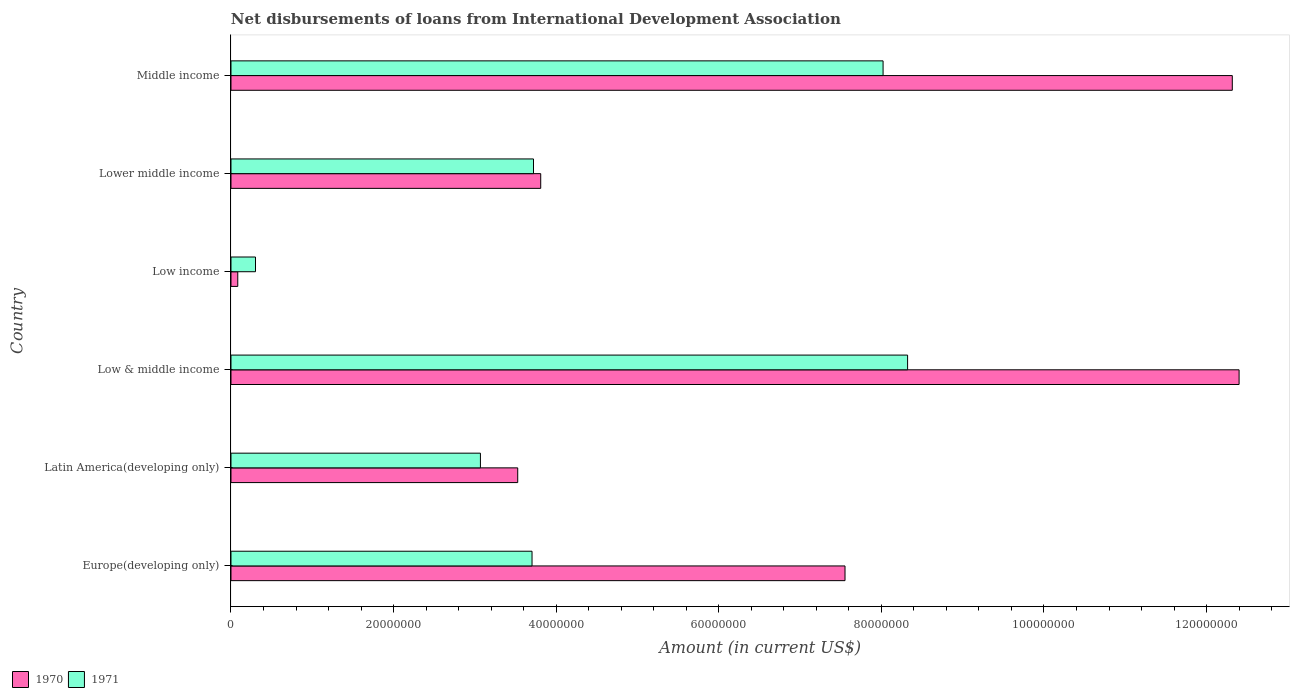How many different coloured bars are there?
Give a very brief answer. 2. Are the number of bars on each tick of the Y-axis equal?
Provide a short and direct response. Yes. How many bars are there on the 6th tick from the top?
Ensure brevity in your answer.  2. How many bars are there on the 1st tick from the bottom?
Your answer should be compact. 2. What is the amount of loans disbursed in 1971 in Middle income?
Offer a terse response. 8.02e+07. Across all countries, what is the maximum amount of loans disbursed in 1971?
Offer a very short reply. 8.32e+07. Across all countries, what is the minimum amount of loans disbursed in 1971?
Provide a succinct answer. 3.02e+06. In which country was the amount of loans disbursed in 1970 maximum?
Your answer should be very brief. Low & middle income. What is the total amount of loans disbursed in 1970 in the graph?
Offer a terse response. 3.97e+08. What is the difference between the amount of loans disbursed in 1971 in Low income and that in Middle income?
Your response must be concise. -7.72e+07. What is the difference between the amount of loans disbursed in 1971 in Low & middle income and the amount of loans disbursed in 1970 in Latin America(developing only)?
Your answer should be very brief. 4.80e+07. What is the average amount of loans disbursed in 1970 per country?
Provide a succinct answer. 6.61e+07. What is the difference between the amount of loans disbursed in 1971 and amount of loans disbursed in 1970 in Middle income?
Keep it short and to the point. -4.30e+07. In how many countries, is the amount of loans disbursed in 1970 greater than 68000000 US$?
Your answer should be very brief. 3. What is the ratio of the amount of loans disbursed in 1970 in Low income to that in Middle income?
Ensure brevity in your answer.  0.01. Is the amount of loans disbursed in 1970 in Europe(developing only) less than that in Low income?
Make the answer very short. No. What is the difference between the highest and the second highest amount of loans disbursed in 1971?
Keep it short and to the point. 3.02e+06. What is the difference between the highest and the lowest amount of loans disbursed in 1971?
Make the answer very short. 8.02e+07. How many countries are there in the graph?
Your answer should be very brief. 6. Are the values on the major ticks of X-axis written in scientific E-notation?
Offer a very short reply. No. What is the title of the graph?
Your answer should be very brief. Net disbursements of loans from International Development Association. Does "1991" appear as one of the legend labels in the graph?
Offer a terse response. No. What is the label or title of the Y-axis?
Give a very brief answer. Country. What is the Amount (in current US$) in 1970 in Europe(developing only)?
Your response must be concise. 7.55e+07. What is the Amount (in current US$) in 1971 in Europe(developing only)?
Ensure brevity in your answer.  3.70e+07. What is the Amount (in current US$) in 1970 in Latin America(developing only)?
Make the answer very short. 3.53e+07. What is the Amount (in current US$) in 1971 in Latin America(developing only)?
Ensure brevity in your answer.  3.07e+07. What is the Amount (in current US$) of 1970 in Low & middle income?
Make the answer very short. 1.24e+08. What is the Amount (in current US$) in 1971 in Low & middle income?
Offer a very short reply. 8.32e+07. What is the Amount (in current US$) in 1970 in Low income?
Your response must be concise. 8.35e+05. What is the Amount (in current US$) in 1971 in Low income?
Keep it short and to the point. 3.02e+06. What is the Amount (in current US$) in 1970 in Lower middle income?
Make the answer very short. 3.81e+07. What is the Amount (in current US$) of 1971 in Lower middle income?
Keep it short and to the point. 3.72e+07. What is the Amount (in current US$) of 1970 in Middle income?
Ensure brevity in your answer.  1.23e+08. What is the Amount (in current US$) in 1971 in Middle income?
Offer a very short reply. 8.02e+07. Across all countries, what is the maximum Amount (in current US$) in 1970?
Your answer should be compact. 1.24e+08. Across all countries, what is the maximum Amount (in current US$) in 1971?
Make the answer very short. 8.32e+07. Across all countries, what is the minimum Amount (in current US$) of 1970?
Your answer should be very brief. 8.35e+05. Across all countries, what is the minimum Amount (in current US$) in 1971?
Make the answer very short. 3.02e+06. What is the total Amount (in current US$) in 1970 in the graph?
Offer a very short reply. 3.97e+08. What is the total Amount (in current US$) of 1971 in the graph?
Provide a short and direct response. 2.71e+08. What is the difference between the Amount (in current US$) in 1970 in Europe(developing only) and that in Latin America(developing only)?
Give a very brief answer. 4.03e+07. What is the difference between the Amount (in current US$) of 1971 in Europe(developing only) and that in Latin America(developing only)?
Offer a very short reply. 6.35e+06. What is the difference between the Amount (in current US$) in 1970 in Europe(developing only) and that in Low & middle income?
Provide a short and direct response. -4.85e+07. What is the difference between the Amount (in current US$) in 1971 in Europe(developing only) and that in Low & middle income?
Offer a very short reply. -4.62e+07. What is the difference between the Amount (in current US$) of 1970 in Europe(developing only) and that in Low income?
Your response must be concise. 7.47e+07. What is the difference between the Amount (in current US$) in 1971 in Europe(developing only) and that in Low income?
Your response must be concise. 3.40e+07. What is the difference between the Amount (in current US$) in 1970 in Europe(developing only) and that in Lower middle income?
Offer a terse response. 3.74e+07. What is the difference between the Amount (in current US$) in 1971 in Europe(developing only) and that in Lower middle income?
Ensure brevity in your answer.  -1.81e+05. What is the difference between the Amount (in current US$) in 1970 in Europe(developing only) and that in Middle income?
Provide a succinct answer. -4.76e+07. What is the difference between the Amount (in current US$) of 1971 in Europe(developing only) and that in Middle income?
Make the answer very short. -4.32e+07. What is the difference between the Amount (in current US$) of 1970 in Latin America(developing only) and that in Low & middle income?
Ensure brevity in your answer.  -8.87e+07. What is the difference between the Amount (in current US$) of 1971 in Latin America(developing only) and that in Low & middle income?
Your answer should be very brief. -5.25e+07. What is the difference between the Amount (in current US$) in 1970 in Latin America(developing only) and that in Low income?
Offer a very short reply. 3.44e+07. What is the difference between the Amount (in current US$) of 1971 in Latin America(developing only) and that in Low income?
Offer a very short reply. 2.77e+07. What is the difference between the Amount (in current US$) of 1970 in Latin America(developing only) and that in Lower middle income?
Your answer should be compact. -2.83e+06. What is the difference between the Amount (in current US$) in 1971 in Latin America(developing only) and that in Lower middle income?
Your answer should be compact. -6.53e+06. What is the difference between the Amount (in current US$) of 1970 in Latin America(developing only) and that in Middle income?
Offer a very short reply. -8.79e+07. What is the difference between the Amount (in current US$) in 1971 in Latin America(developing only) and that in Middle income?
Offer a very short reply. -4.95e+07. What is the difference between the Amount (in current US$) in 1970 in Low & middle income and that in Low income?
Make the answer very short. 1.23e+08. What is the difference between the Amount (in current US$) in 1971 in Low & middle income and that in Low income?
Ensure brevity in your answer.  8.02e+07. What is the difference between the Amount (in current US$) of 1970 in Low & middle income and that in Lower middle income?
Make the answer very short. 8.59e+07. What is the difference between the Amount (in current US$) in 1971 in Low & middle income and that in Lower middle income?
Provide a succinct answer. 4.60e+07. What is the difference between the Amount (in current US$) of 1970 in Low & middle income and that in Middle income?
Provide a short and direct response. 8.35e+05. What is the difference between the Amount (in current US$) of 1971 in Low & middle income and that in Middle income?
Your response must be concise. 3.02e+06. What is the difference between the Amount (in current US$) of 1970 in Low income and that in Lower middle income?
Offer a terse response. -3.73e+07. What is the difference between the Amount (in current US$) of 1971 in Low income and that in Lower middle income?
Your response must be concise. -3.42e+07. What is the difference between the Amount (in current US$) of 1970 in Low income and that in Middle income?
Your answer should be very brief. -1.22e+08. What is the difference between the Amount (in current US$) of 1971 in Low income and that in Middle income?
Provide a short and direct response. -7.72e+07. What is the difference between the Amount (in current US$) of 1970 in Lower middle income and that in Middle income?
Your answer should be very brief. -8.51e+07. What is the difference between the Amount (in current US$) of 1971 in Lower middle income and that in Middle income?
Give a very brief answer. -4.30e+07. What is the difference between the Amount (in current US$) of 1970 in Europe(developing only) and the Amount (in current US$) of 1971 in Latin America(developing only)?
Give a very brief answer. 4.48e+07. What is the difference between the Amount (in current US$) of 1970 in Europe(developing only) and the Amount (in current US$) of 1971 in Low & middle income?
Your response must be concise. -7.70e+06. What is the difference between the Amount (in current US$) of 1970 in Europe(developing only) and the Amount (in current US$) of 1971 in Low income?
Keep it short and to the point. 7.25e+07. What is the difference between the Amount (in current US$) of 1970 in Europe(developing only) and the Amount (in current US$) of 1971 in Lower middle income?
Offer a terse response. 3.83e+07. What is the difference between the Amount (in current US$) of 1970 in Europe(developing only) and the Amount (in current US$) of 1971 in Middle income?
Your answer should be compact. -4.68e+06. What is the difference between the Amount (in current US$) of 1970 in Latin America(developing only) and the Amount (in current US$) of 1971 in Low & middle income?
Your answer should be very brief. -4.80e+07. What is the difference between the Amount (in current US$) of 1970 in Latin America(developing only) and the Amount (in current US$) of 1971 in Low income?
Provide a short and direct response. 3.23e+07. What is the difference between the Amount (in current US$) in 1970 in Latin America(developing only) and the Amount (in current US$) in 1971 in Lower middle income?
Offer a terse response. -1.94e+06. What is the difference between the Amount (in current US$) of 1970 in Latin America(developing only) and the Amount (in current US$) of 1971 in Middle income?
Your response must be concise. -4.49e+07. What is the difference between the Amount (in current US$) in 1970 in Low & middle income and the Amount (in current US$) in 1971 in Low income?
Keep it short and to the point. 1.21e+08. What is the difference between the Amount (in current US$) in 1970 in Low & middle income and the Amount (in current US$) in 1971 in Lower middle income?
Make the answer very short. 8.68e+07. What is the difference between the Amount (in current US$) in 1970 in Low & middle income and the Amount (in current US$) in 1971 in Middle income?
Give a very brief answer. 4.38e+07. What is the difference between the Amount (in current US$) in 1970 in Low income and the Amount (in current US$) in 1971 in Lower middle income?
Your answer should be compact. -3.64e+07. What is the difference between the Amount (in current US$) of 1970 in Low income and the Amount (in current US$) of 1971 in Middle income?
Keep it short and to the point. -7.94e+07. What is the difference between the Amount (in current US$) in 1970 in Lower middle income and the Amount (in current US$) in 1971 in Middle income?
Your answer should be compact. -4.21e+07. What is the average Amount (in current US$) of 1970 per country?
Your response must be concise. 6.61e+07. What is the average Amount (in current US$) of 1971 per country?
Offer a terse response. 4.52e+07. What is the difference between the Amount (in current US$) of 1970 and Amount (in current US$) of 1971 in Europe(developing only)?
Ensure brevity in your answer.  3.85e+07. What is the difference between the Amount (in current US$) of 1970 and Amount (in current US$) of 1971 in Latin America(developing only)?
Keep it short and to the point. 4.59e+06. What is the difference between the Amount (in current US$) in 1970 and Amount (in current US$) in 1971 in Low & middle income?
Your response must be concise. 4.08e+07. What is the difference between the Amount (in current US$) of 1970 and Amount (in current US$) of 1971 in Low income?
Give a very brief answer. -2.18e+06. What is the difference between the Amount (in current US$) of 1970 and Amount (in current US$) of 1971 in Lower middle income?
Your answer should be compact. 8.88e+05. What is the difference between the Amount (in current US$) of 1970 and Amount (in current US$) of 1971 in Middle income?
Ensure brevity in your answer.  4.30e+07. What is the ratio of the Amount (in current US$) of 1970 in Europe(developing only) to that in Latin America(developing only)?
Your answer should be very brief. 2.14. What is the ratio of the Amount (in current US$) in 1971 in Europe(developing only) to that in Latin America(developing only)?
Offer a terse response. 1.21. What is the ratio of the Amount (in current US$) of 1970 in Europe(developing only) to that in Low & middle income?
Give a very brief answer. 0.61. What is the ratio of the Amount (in current US$) in 1971 in Europe(developing only) to that in Low & middle income?
Make the answer very short. 0.44. What is the ratio of the Amount (in current US$) in 1970 in Europe(developing only) to that in Low income?
Make the answer very short. 90.45. What is the ratio of the Amount (in current US$) in 1971 in Europe(developing only) to that in Low income?
Provide a short and direct response. 12.28. What is the ratio of the Amount (in current US$) in 1970 in Europe(developing only) to that in Lower middle income?
Provide a short and direct response. 1.98. What is the ratio of the Amount (in current US$) of 1971 in Europe(developing only) to that in Lower middle income?
Provide a succinct answer. 1. What is the ratio of the Amount (in current US$) in 1970 in Europe(developing only) to that in Middle income?
Provide a succinct answer. 0.61. What is the ratio of the Amount (in current US$) in 1971 in Europe(developing only) to that in Middle income?
Make the answer very short. 0.46. What is the ratio of the Amount (in current US$) of 1970 in Latin America(developing only) to that in Low & middle income?
Make the answer very short. 0.28. What is the ratio of the Amount (in current US$) of 1971 in Latin America(developing only) to that in Low & middle income?
Your response must be concise. 0.37. What is the ratio of the Amount (in current US$) in 1970 in Latin America(developing only) to that in Low income?
Give a very brief answer. 42.24. What is the ratio of the Amount (in current US$) of 1971 in Latin America(developing only) to that in Low income?
Make the answer very short. 10.17. What is the ratio of the Amount (in current US$) of 1970 in Latin America(developing only) to that in Lower middle income?
Keep it short and to the point. 0.93. What is the ratio of the Amount (in current US$) of 1971 in Latin America(developing only) to that in Lower middle income?
Your answer should be compact. 0.82. What is the ratio of the Amount (in current US$) in 1970 in Latin America(developing only) to that in Middle income?
Provide a succinct answer. 0.29. What is the ratio of the Amount (in current US$) in 1971 in Latin America(developing only) to that in Middle income?
Offer a very short reply. 0.38. What is the ratio of the Amount (in current US$) in 1970 in Low & middle income to that in Low income?
Your answer should be compact. 148.5. What is the ratio of the Amount (in current US$) of 1971 in Low & middle income to that in Low income?
Ensure brevity in your answer.  27.59. What is the ratio of the Amount (in current US$) of 1970 in Low & middle income to that in Lower middle income?
Provide a succinct answer. 3.25. What is the ratio of the Amount (in current US$) in 1971 in Low & middle income to that in Lower middle income?
Your response must be concise. 2.24. What is the ratio of the Amount (in current US$) in 1970 in Low & middle income to that in Middle income?
Keep it short and to the point. 1.01. What is the ratio of the Amount (in current US$) in 1971 in Low & middle income to that in Middle income?
Provide a succinct answer. 1.04. What is the ratio of the Amount (in current US$) of 1970 in Low income to that in Lower middle income?
Ensure brevity in your answer.  0.02. What is the ratio of the Amount (in current US$) in 1971 in Low income to that in Lower middle income?
Make the answer very short. 0.08. What is the ratio of the Amount (in current US$) in 1970 in Low income to that in Middle income?
Offer a very short reply. 0.01. What is the ratio of the Amount (in current US$) of 1971 in Low income to that in Middle income?
Keep it short and to the point. 0.04. What is the ratio of the Amount (in current US$) in 1970 in Lower middle income to that in Middle income?
Ensure brevity in your answer.  0.31. What is the ratio of the Amount (in current US$) of 1971 in Lower middle income to that in Middle income?
Your response must be concise. 0.46. What is the difference between the highest and the second highest Amount (in current US$) of 1970?
Offer a terse response. 8.35e+05. What is the difference between the highest and the second highest Amount (in current US$) of 1971?
Make the answer very short. 3.02e+06. What is the difference between the highest and the lowest Amount (in current US$) in 1970?
Your answer should be very brief. 1.23e+08. What is the difference between the highest and the lowest Amount (in current US$) of 1971?
Give a very brief answer. 8.02e+07. 